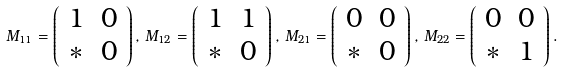Convert formula to latex. <formula><loc_0><loc_0><loc_500><loc_500>M _ { 1 1 } = \left ( \begin{array} { c c } 1 & 0 \\ * & 0 \end{array} \right ) , \, M _ { 1 2 } = \left ( \begin{array} { c c } 1 & 1 \\ * & 0 \end{array} \right ) , \, M _ { 2 1 } = \left ( \begin{array} { c c } 0 & 0 \\ * & 0 \end{array} \right ) , \, M _ { 2 2 } = \left ( \begin{array} { c c } 0 & 0 \\ * & 1 \end{array} \right ) .</formula> 